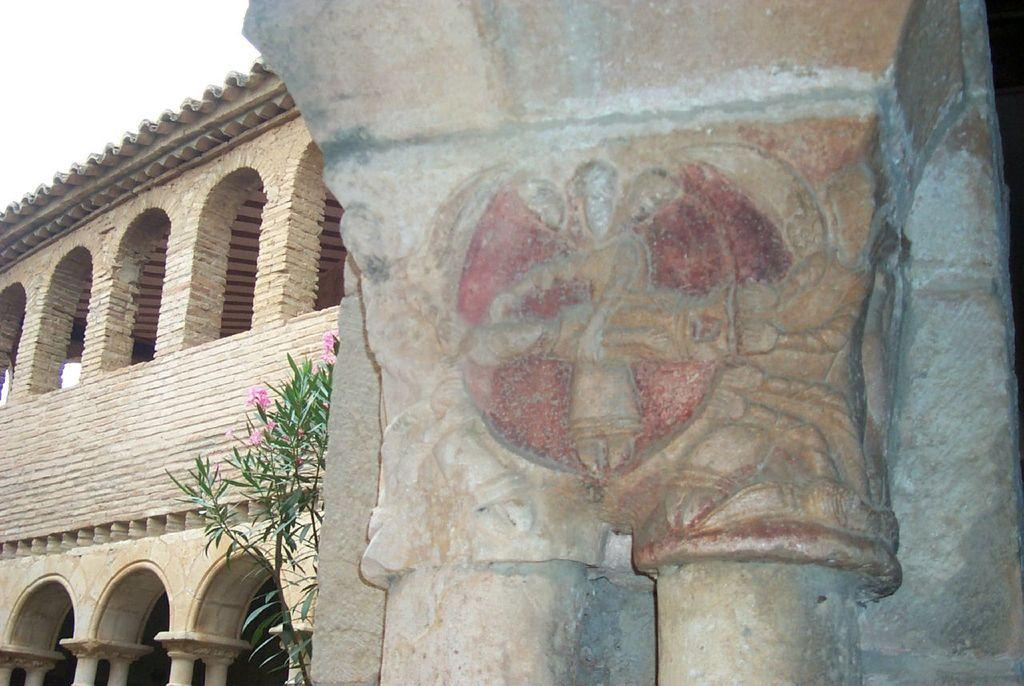What can be seen on the wall in the image? There are designs on the wall in the image. What is located on the left side of the image? There is a plant and a building on the left side of the image. Can you see a jar filled with water and a rat swimming in it on the right side of the image? No, there is no jar or rat present in the image. 